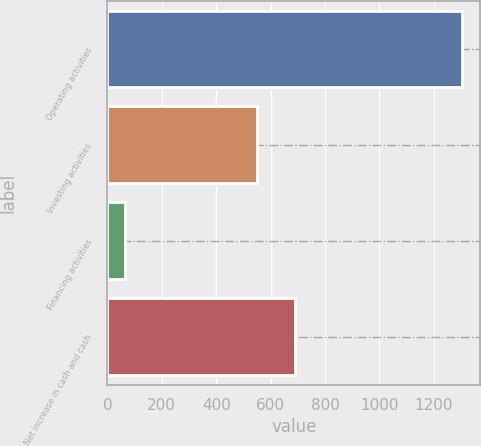<chart> <loc_0><loc_0><loc_500><loc_500><bar_chart><fcel>Operating activities<fcel>Investing activities<fcel>Financing activities<fcel>Net increase in cash and cash<nl><fcel>1305<fcel>551<fcel>64<fcel>690<nl></chart> 